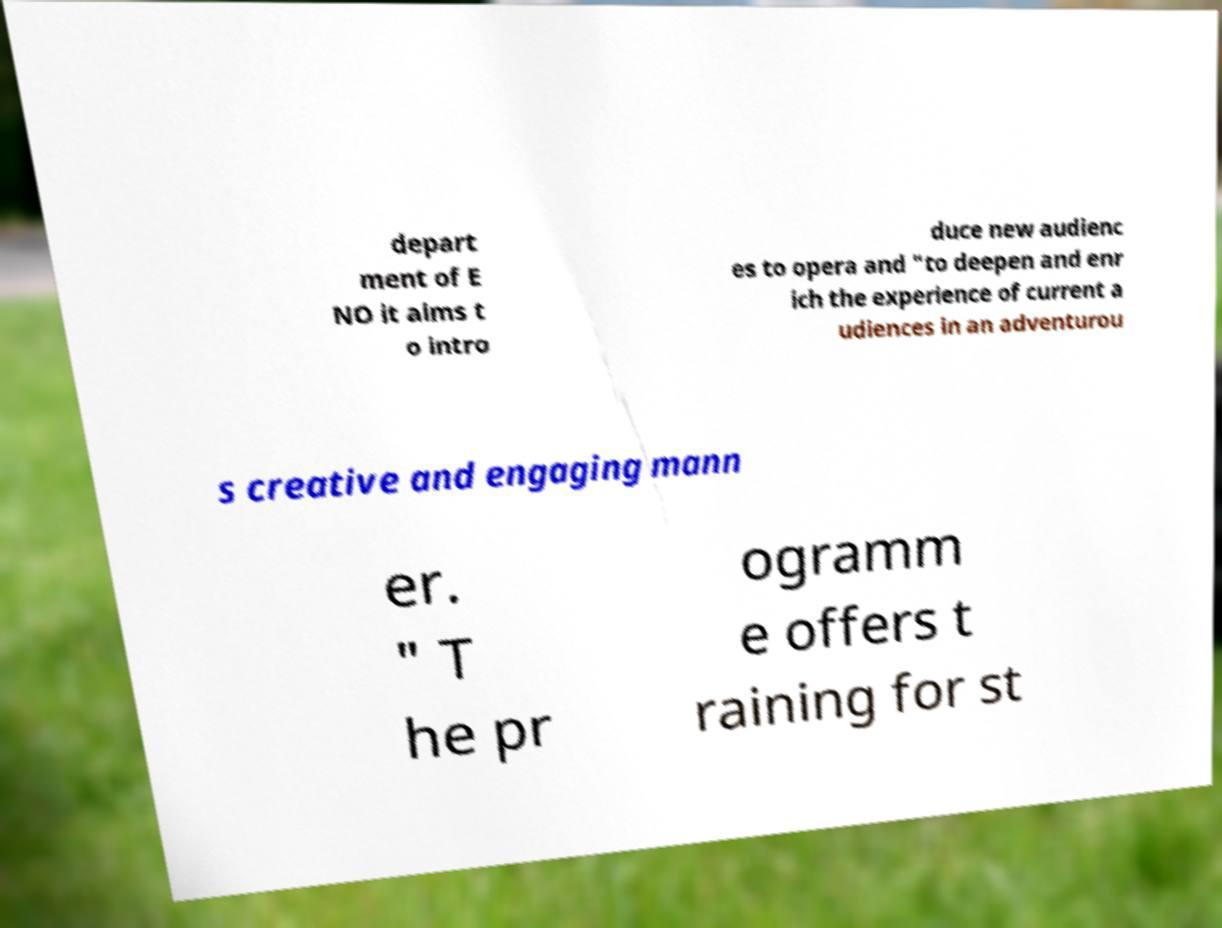There's text embedded in this image that I need extracted. Can you transcribe it verbatim? depart ment of E NO it aims t o intro duce new audienc es to opera and "to deepen and enr ich the experience of current a udiences in an adventurou s creative and engaging mann er. " T he pr ogramm e offers t raining for st 